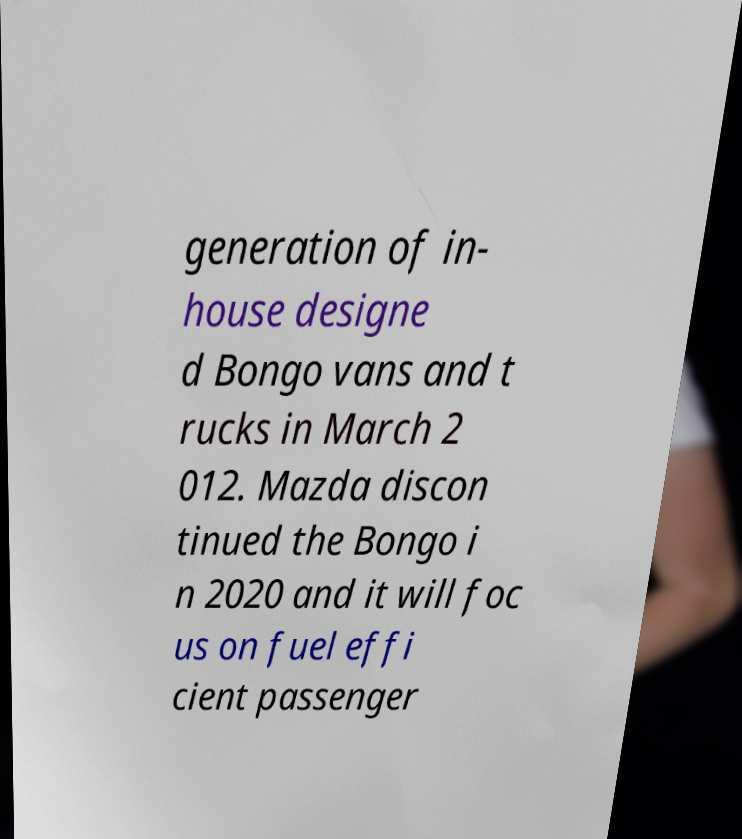Can you accurately transcribe the text from the provided image for me? generation of in- house designe d Bongo vans and t rucks in March 2 012. Mazda discon tinued the Bongo i n 2020 and it will foc us on fuel effi cient passenger 